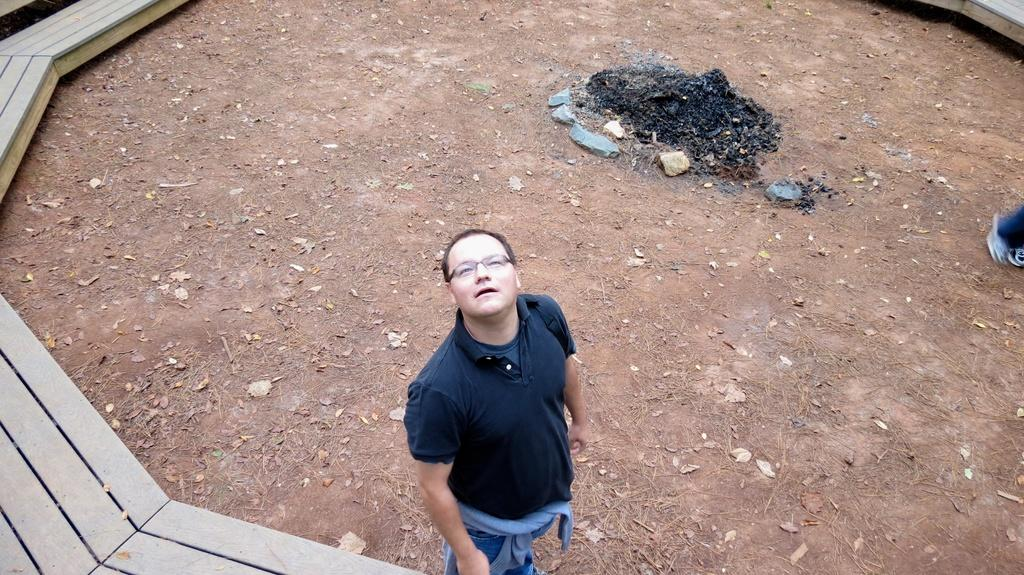What is the main subject of the image? There is a man standing in the image. Where is the man standing? The man is standing on the ground. What can be seen on the left side of the image? There is a wooden platform on the left side of the image. What song is the man singing in the image? There is no indication in the image that the man is singing a song, so it cannot be determined from the picture. 